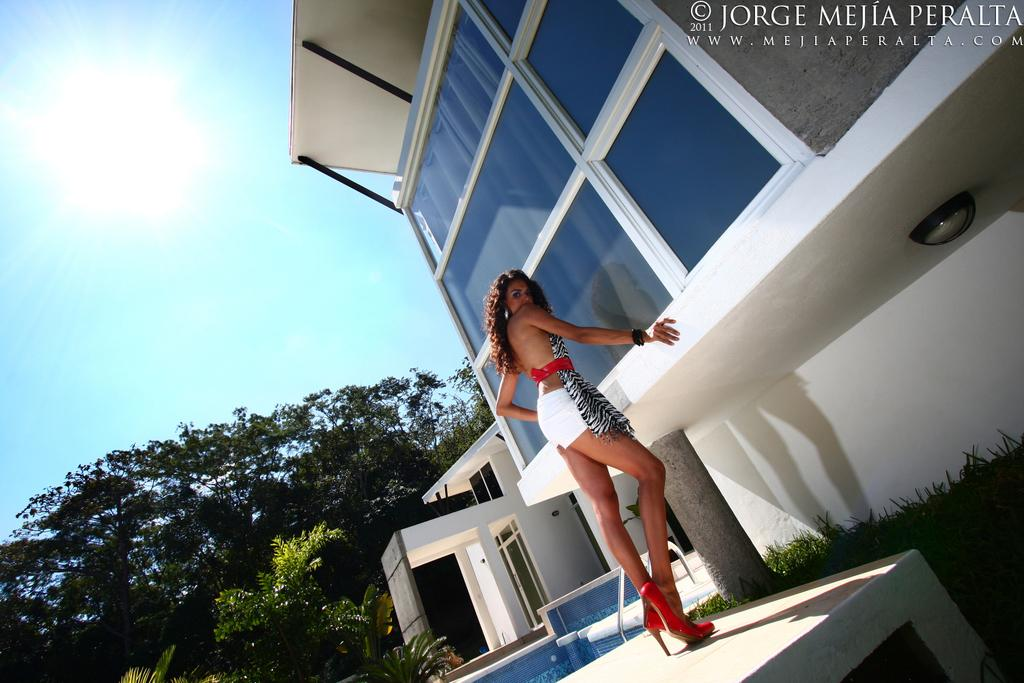Who is the main subject in the image? There is a girl in the center of the image. What structure can be seen at the top side of the image? There is a building at the top side of the image. What type of vegetation is on the left side of the image? There are trees on the left side of the image. What type of sea creature can be seen swimming near the girl in the image? There is no sea creature present in the image; it features a girl, a building, and trees. 